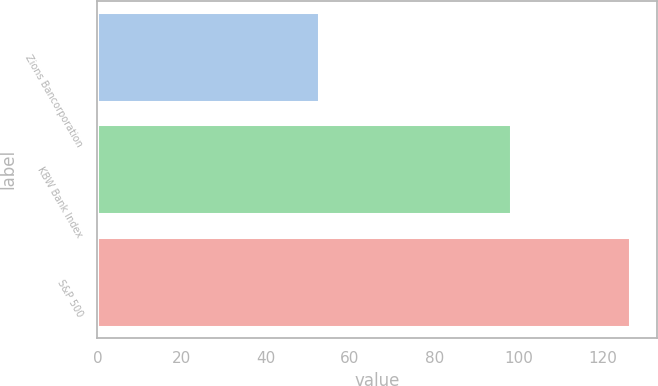Convert chart to OTSL. <chart><loc_0><loc_0><loc_500><loc_500><bar_chart><fcel>Zions Bancorporation<fcel>KBW Bank Index<fcel>S&P 500<nl><fcel>52.7<fcel>98.3<fcel>126.5<nl></chart> 